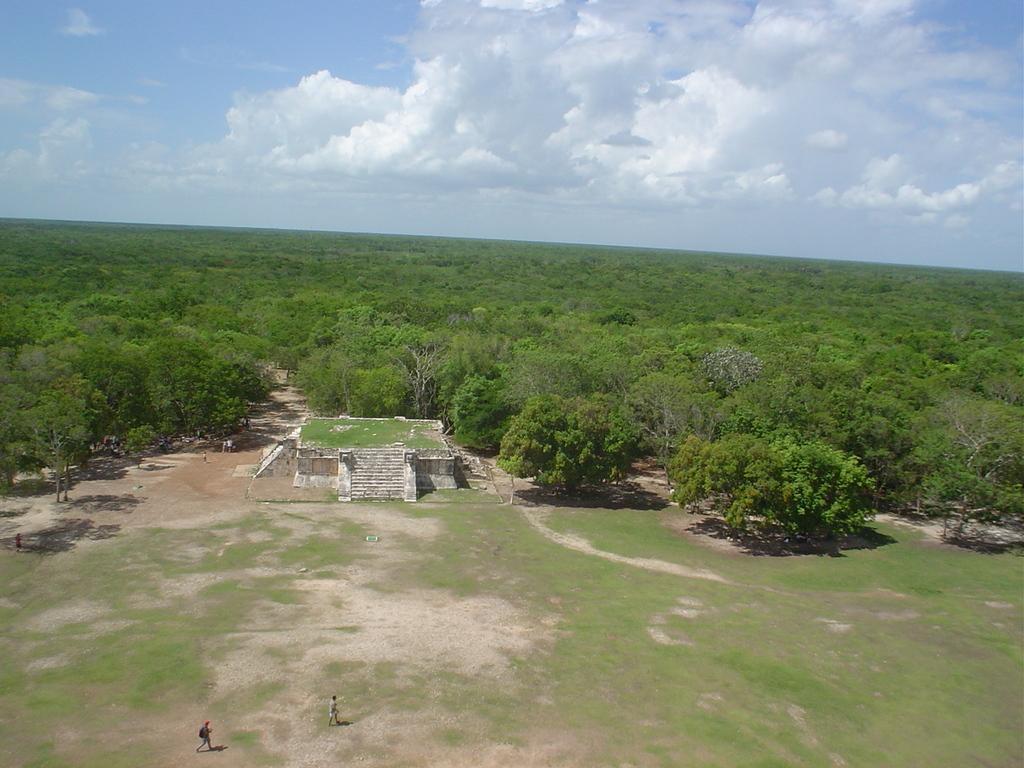Could you give a brief overview of what you see in this image? In the image there is a stone monument in the middle of the grassland and behind it there are trees all over the place and above its sky with clouds. 